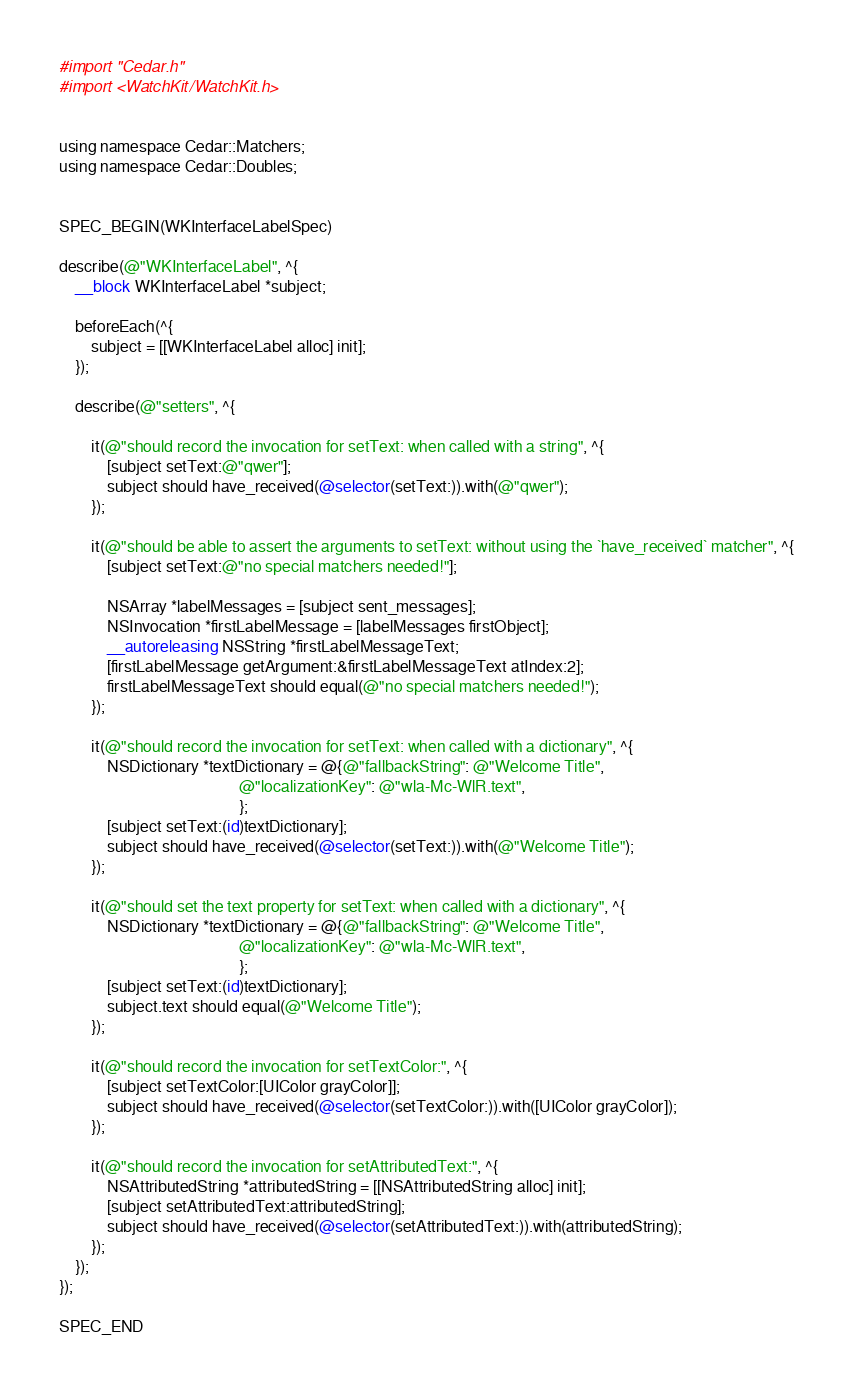<code> <loc_0><loc_0><loc_500><loc_500><_ObjectiveC_>#import "Cedar.h"
#import <WatchKit/WatchKit.h>


using namespace Cedar::Matchers;
using namespace Cedar::Doubles;


SPEC_BEGIN(WKInterfaceLabelSpec)

describe(@"WKInterfaceLabel", ^{
    __block WKInterfaceLabel *subject;

    beforeEach(^{
        subject = [[WKInterfaceLabel alloc] init];
    });

    describe(@"setters", ^{

        it(@"should record the invocation for setText: when called with a string", ^{
            [subject setText:@"qwer"];
            subject should have_received(@selector(setText:)).with(@"qwer");
        });

        it(@"should be able to assert the arguments to setText: without using the `have_received` matcher", ^{
            [subject setText:@"no special matchers needed!"];

            NSArray *labelMessages = [subject sent_messages];
            NSInvocation *firstLabelMessage = [labelMessages firstObject];
            __autoreleasing NSString *firstLabelMessageText;
            [firstLabelMessage getArgument:&firstLabelMessageText atIndex:2];
            firstLabelMessageText should equal(@"no special matchers needed!");
        });

        it(@"should record the invocation for setText: when called with a dictionary", ^{
            NSDictionary *textDictionary = @{@"fallbackString": @"Welcome Title",
                                             @"localizationKey": @"wla-Mc-WlR.text",
                                             };
            [subject setText:(id)textDictionary];
            subject should have_received(@selector(setText:)).with(@"Welcome Title");
        });

        it(@"should set the text property for setText: when called with a dictionary", ^{
            NSDictionary *textDictionary = @{@"fallbackString": @"Welcome Title",
                                             @"localizationKey": @"wla-Mc-WlR.text",
                                             };
            [subject setText:(id)textDictionary];
            subject.text should equal(@"Welcome Title");
        });

        it(@"should record the invocation for setTextColor:", ^{
            [subject setTextColor:[UIColor grayColor]];
            subject should have_received(@selector(setTextColor:)).with([UIColor grayColor]);
        });

        it(@"should record the invocation for setAttributedText:", ^{
            NSAttributedString *attributedString = [[NSAttributedString alloc] init];
            [subject setAttributedText:attributedString];
            subject should have_received(@selector(setAttributedText:)).with(attributedString);
        });
    });
});

SPEC_END
</code> 